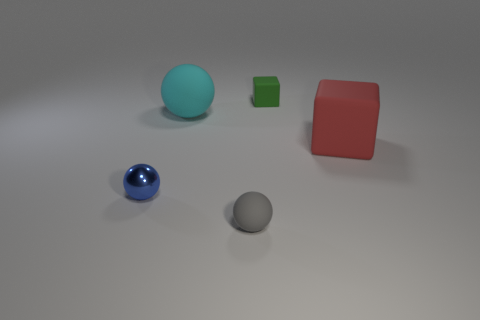There is a matte thing that is behind the large thing that is behind the cube to the right of the green rubber object; what is its shape?
Your answer should be very brief. Cube. There is a tiny object in front of the small blue ball; is its shape the same as the object that is on the left side of the cyan matte ball?
Give a very brief answer. Yes. Is there any other thing that is the same size as the red block?
Ensure brevity in your answer.  Yes. What number of balls are large gray matte objects or tiny gray things?
Provide a short and direct response. 1. Is the material of the small blue thing the same as the small green cube?
Provide a succinct answer. No. How many other things are there of the same color as the tiny metal sphere?
Offer a very short reply. 0. There is a large cyan object to the left of the red rubber block; what is its shape?
Give a very brief answer. Sphere. How many objects are either green rubber objects or tiny gray matte balls?
Keep it short and to the point. 2. There is a blue metallic ball; is it the same size as the cyan object that is left of the small gray sphere?
Give a very brief answer. No. What number of other objects are the same material as the blue thing?
Your response must be concise. 0. 